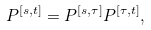<formula> <loc_0><loc_0><loc_500><loc_500>P ^ { [ s , t ] } = P ^ { [ s , \tau ] } P ^ { [ \tau , t ] } ,</formula> 